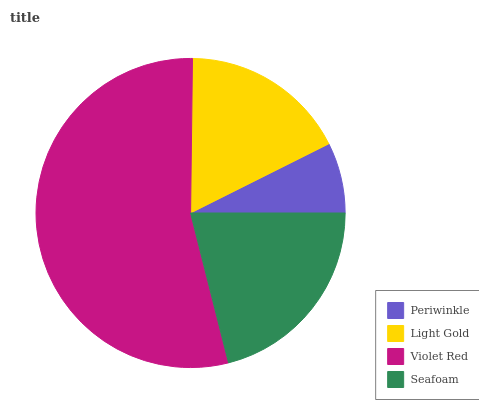Is Periwinkle the minimum?
Answer yes or no. Yes. Is Violet Red the maximum?
Answer yes or no. Yes. Is Light Gold the minimum?
Answer yes or no. No. Is Light Gold the maximum?
Answer yes or no. No. Is Light Gold greater than Periwinkle?
Answer yes or no. Yes. Is Periwinkle less than Light Gold?
Answer yes or no. Yes. Is Periwinkle greater than Light Gold?
Answer yes or no. No. Is Light Gold less than Periwinkle?
Answer yes or no. No. Is Seafoam the high median?
Answer yes or no. Yes. Is Light Gold the low median?
Answer yes or no. Yes. Is Periwinkle the high median?
Answer yes or no. No. Is Seafoam the low median?
Answer yes or no. No. 